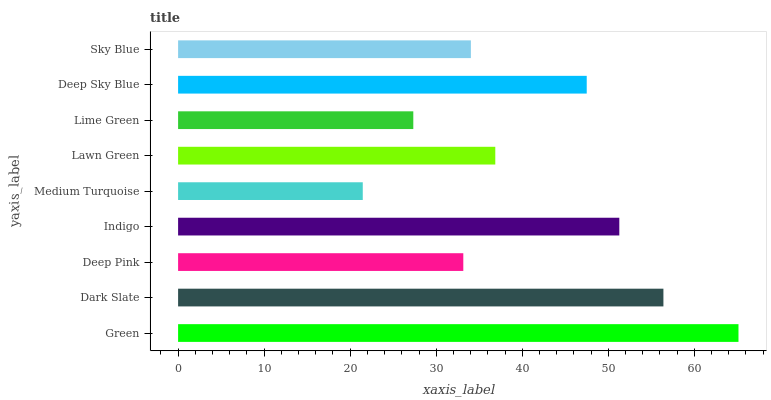Is Medium Turquoise the minimum?
Answer yes or no. Yes. Is Green the maximum?
Answer yes or no. Yes. Is Dark Slate the minimum?
Answer yes or no. No. Is Dark Slate the maximum?
Answer yes or no. No. Is Green greater than Dark Slate?
Answer yes or no. Yes. Is Dark Slate less than Green?
Answer yes or no. Yes. Is Dark Slate greater than Green?
Answer yes or no. No. Is Green less than Dark Slate?
Answer yes or no. No. Is Lawn Green the high median?
Answer yes or no. Yes. Is Lawn Green the low median?
Answer yes or no. Yes. Is Indigo the high median?
Answer yes or no. No. Is Sky Blue the low median?
Answer yes or no. No. 